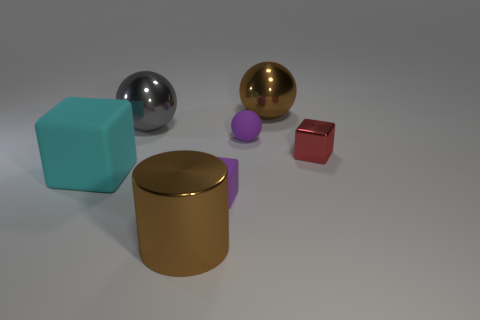Could you describe the lighting in the scene? The lighting in the image appears to be soft and diffused, creating gentle shadows on the ground beneath the objects. The light source is coming from the upper right side, as indicated by the direction of the shadows. This lighting gives the objects a three-dimensional appearance and highlights their colors and textures. 